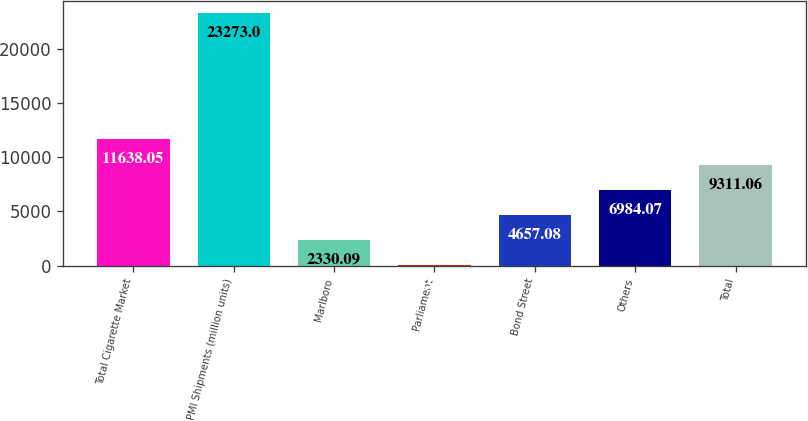Convert chart to OTSL. <chart><loc_0><loc_0><loc_500><loc_500><bar_chart><fcel>Total Cigarette Market<fcel>PMI Shipments (million units)<fcel>Marlboro<fcel>Parliament<fcel>Bond Street<fcel>Others<fcel>Total<nl><fcel>11638<fcel>23273<fcel>2330.09<fcel>3.1<fcel>4657.08<fcel>6984.07<fcel>9311.06<nl></chart> 